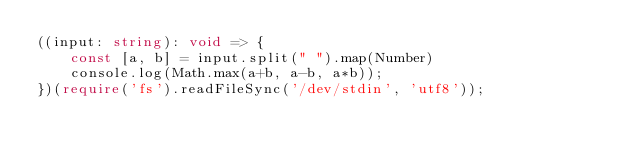<code> <loc_0><loc_0><loc_500><loc_500><_TypeScript_>((input: string): void => {
    const [a, b] = input.split(" ").map(Number)
    console.log(Math.max(a+b, a-b, a*b));
})(require('fs').readFileSync('/dev/stdin', 'utf8'));
</code> 